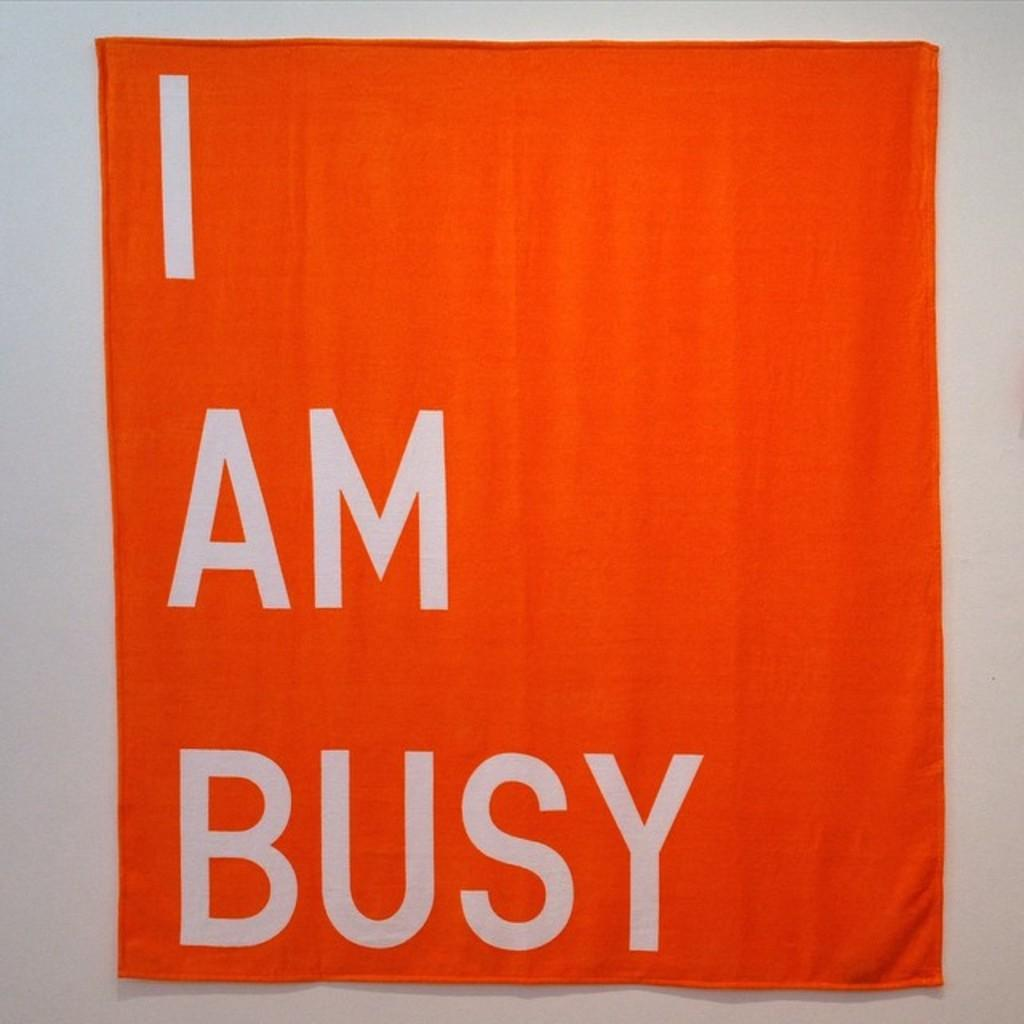<image>
Give a short and clear explanation of the subsequent image. An orange towel hanging from a wall that says I am busy 